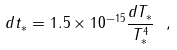<formula> <loc_0><loc_0><loc_500><loc_500>d t _ { * } = 1 . 5 \times 1 0 ^ { - 1 5 } \frac { d T _ { * } } { T _ { * } ^ { 4 } } \ ,</formula> 